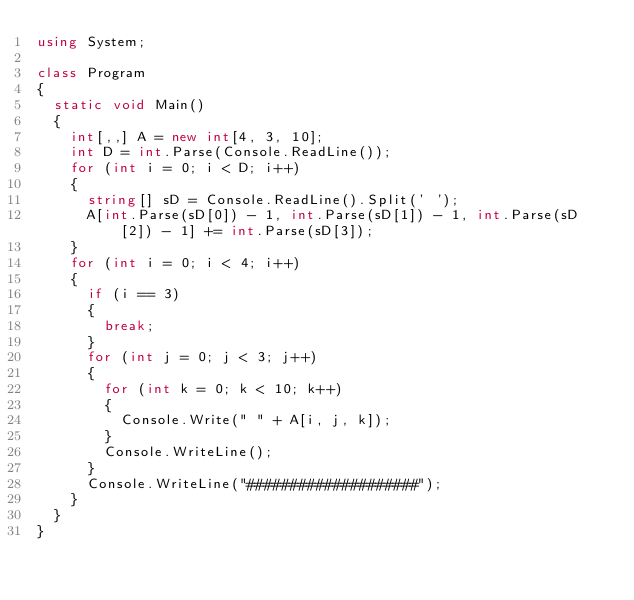Convert code to text. <code><loc_0><loc_0><loc_500><loc_500><_C#_>using System;

class Program
{
	static void Main()
	{
		int[,,] A = new int[4, 3, 10];
		int D = int.Parse(Console.ReadLine());
		for (int i = 0; i < D; i++)
		{
			string[] sD = Console.ReadLine().Split(' ');
			A[int.Parse(sD[0]) - 1, int.Parse(sD[1]) - 1, int.Parse(sD[2]) - 1] += int.Parse(sD[3]);
		}
		for (int i = 0; i < 4; i++)
		{
			if (i == 3)
			{
				break;
			}
			for (int j = 0; j < 3; j++)
			{
				for (int k = 0; k < 10; k++)
				{
					Console.Write(" " + A[i, j, k]);
				}
				Console.WriteLine();
			}
			Console.WriteLine("####################");
		}
	}
}</code> 